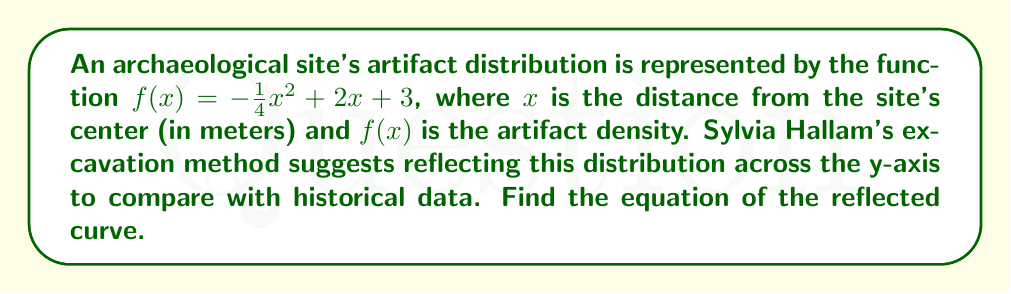Could you help me with this problem? To reflect a curve across the y-axis, we need to replace every $x$ with $-x$ in the original function. This is because reflection across the y-axis changes the sign of the x-coordinate while keeping the y-coordinate the same.

Given function: $f(x) = -\frac{1}{4}x^2 + 2x + 3$

Steps to reflect:

1. Replace every $x$ with $-x$:
   $f(-x) = -\frac{1}{4}(-x)^2 + 2(-x) + 3$

2. Simplify:
   $f(-x) = -\frac{1}{4}x^2 - 2x + 3$

The resulting function $f(-x)$ represents the reflection of the original curve across the y-axis.

To verify, we can check a few properties:
- The constant term (3) remains unchanged, as it represents the y-intercept.
- The coefficient of $x^2$ remains negative, preserving the parabola's orientation.
- The linear term's sign has changed from positive to negative.

This reflection is consistent with Sylvia Hallam's approach to comparing artifact distributions with historical data, allowing archaeologists to analyze symmetry and patterns in the findings across the site.
Answer: The equation of the reflected curve is $f(x) = -\frac{1}{4}x^2 - 2x + 3$ 